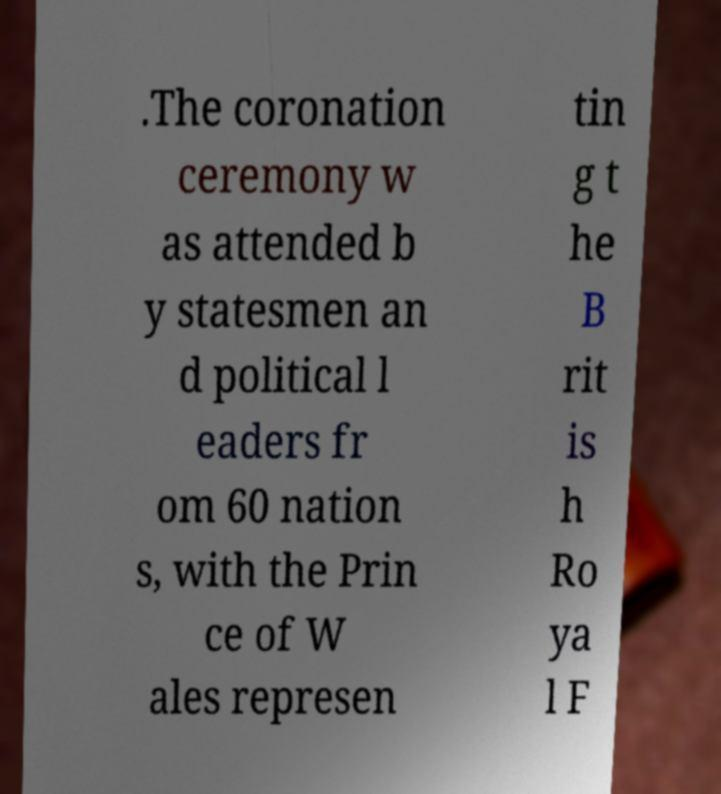For documentation purposes, I need the text within this image transcribed. Could you provide that? .The coronation ceremony w as attended b y statesmen an d political l eaders fr om 60 nation s, with the Prin ce of W ales represen tin g t he B rit is h Ro ya l F 